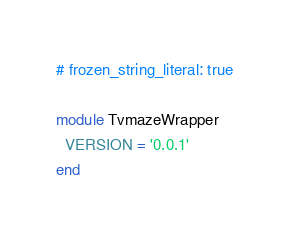<code> <loc_0><loc_0><loc_500><loc_500><_Ruby_># frozen_string_literal: true

module TvmazeWrapper
  VERSION = '0.0.1'
end
</code> 